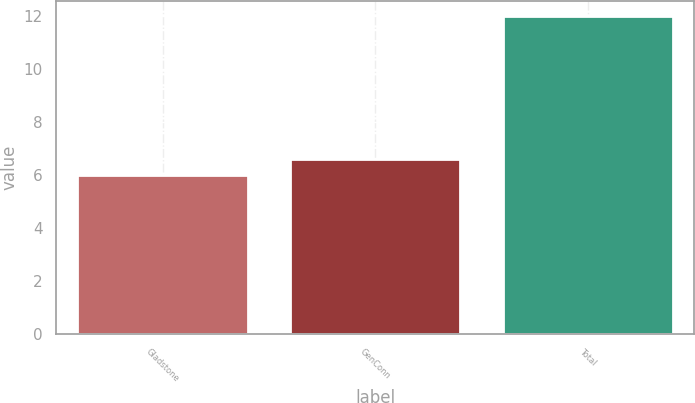<chart> <loc_0><loc_0><loc_500><loc_500><bar_chart><fcel>Gladstone<fcel>GenConn<fcel>Total<nl><fcel>6<fcel>6.6<fcel>12<nl></chart> 